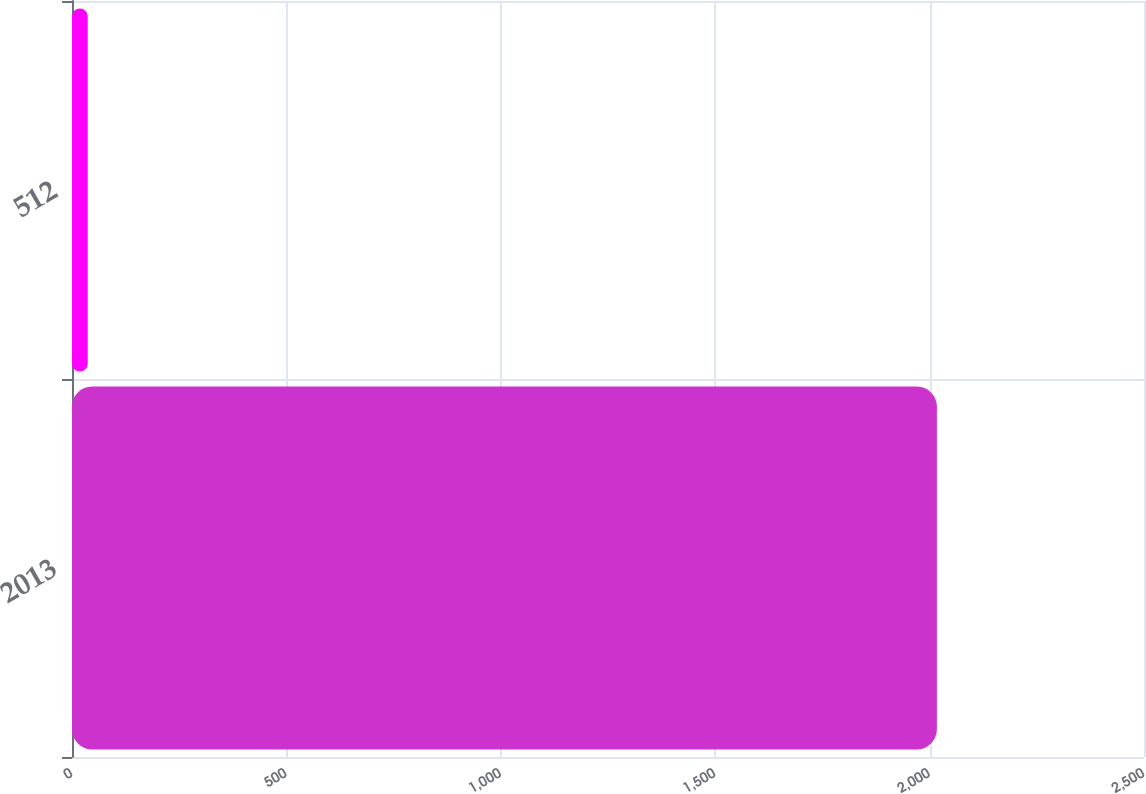Convert chart to OTSL. <chart><loc_0><loc_0><loc_500><loc_500><bar_chart><fcel>2013<fcel>512<nl><fcel>2017<fcel>36.7<nl></chart> 